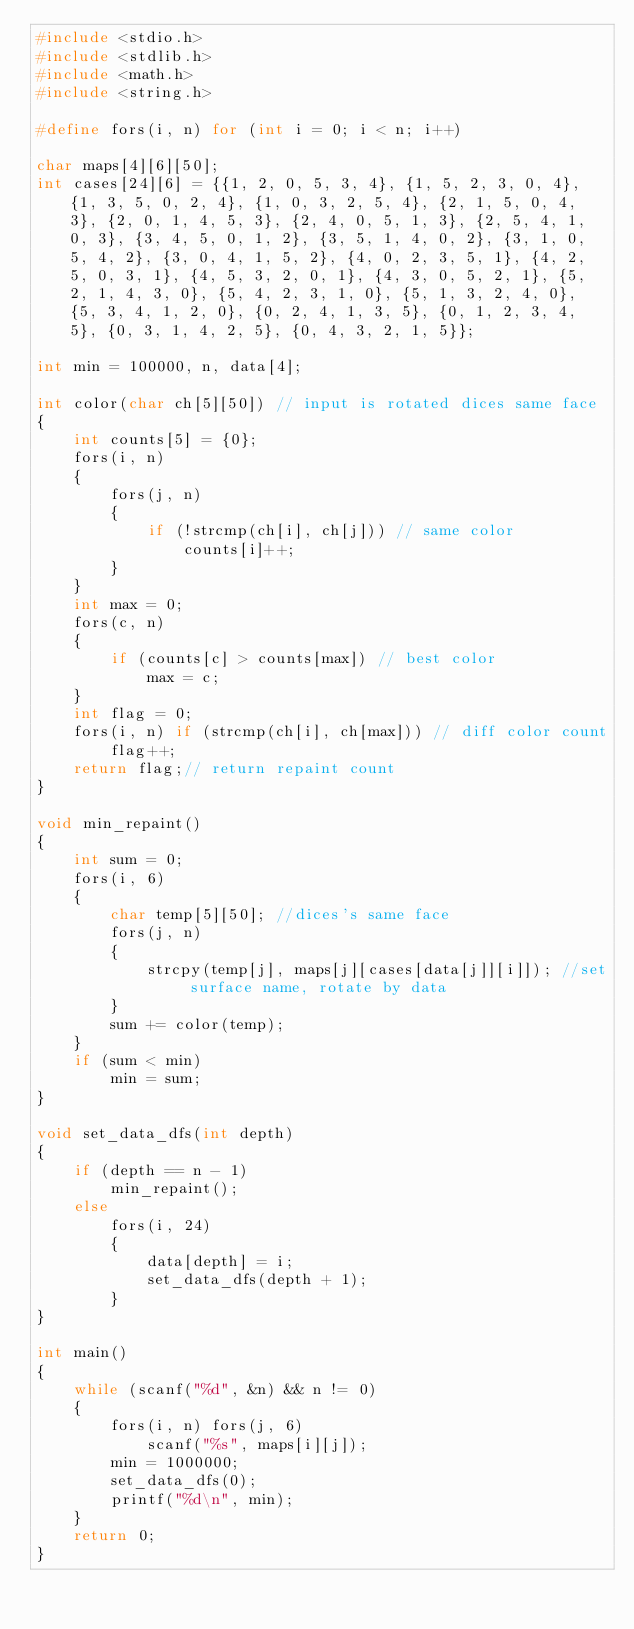<code> <loc_0><loc_0><loc_500><loc_500><_C_>#include <stdio.h>
#include <stdlib.h>
#include <math.h>
#include <string.h>

#define fors(i, n) for (int i = 0; i < n; i++)

char maps[4][6][50];
int cases[24][6] = {{1, 2, 0, 5, 3, 4}, {1, 5, 2, 3, 0, 4}, {1, 3, 5, 0, 2, 4}, {1, 0, 3, 2, 5, 4}, {2, 1, 5, 0, 4, 3}, {2, 0, 1, 4, 5, 3}, {2, 4, 0, 5, 1, 3}, {2, 5, 4, 1, 0, 3}, {3, 4, 5, 0, 1, 2}, {3, 5, 1, 4, 0, 2}, {3, 1, 0, 5, 4, 2}, {3, 0, 4, 1, 5, 2}, {4, 0, 2, 3, 5, 1}, {4, 2, 5, 0, 3, 1}, {4, 5, 3, 2, 0, 1}, {4, 3, 0, 5, 2, 1}, {5, 2, 1, 4, 3, 0}, {5, 4, 2, 3, 1, 0}, {5, 1, 3, 2, 4, 0}, {5, 3, 4, 1, 2, 0}, {0, 2, 4, 1, 3, 5}, {0, 1, 2, 3, 4, 5}, {0, 3, 1, 4, 2, 5}, {0, 4, 3, 2, 1, 5}};

int min = 100000, n, data[4];

int color(char ch[5][50]) // input is rotated dices same face
{
	int counts[5] = {0};
	fors(i, n)
	{
		fors(j, n)
		{
			if (!strcmp(ch[i], ch[j])) // same color
				counts[i]++;
		}
	}
	int max = 0;
	fors(c, n)
	{
		if (counts[c] > counts[max]) // best color
			max = c;
	}
	int flag = 0;
	fors(i, n) if (strcmp(ch[i], ch[max])) // diff color count
		flag++;
	return flag;// return repaint count
}

void min_repaint()
{
	int sum = 0;
	fors(i, 6)
	{
		char temp[5][50]; //dices's same face
		fors(j, n)
		{
			strcpy(temp[j], maps[j][cases[data[j]][i]]); //set surface name, rotate by data
		}
		sum += color(temp);
	}
	if (sum < min)
		min = sum;
}

void set_data_dfs(int depth)
{
	if (depth == n - 1)
		min_repaint();
	else
		fors(i, 24)
		{
			data[depth] = i;
			set_data_dfs(depth + 1);
		}
}

int main()
{
	while (scanf("%d", &n) && n != 0)
	{
		fors(i, n) fors(j, 6)
			scanf("%s", maps[i][j]);
		min = 1000000;
		set_data_dfs(0);
		printf("%d\n", min);
	}
	return 0;
}
</code> 